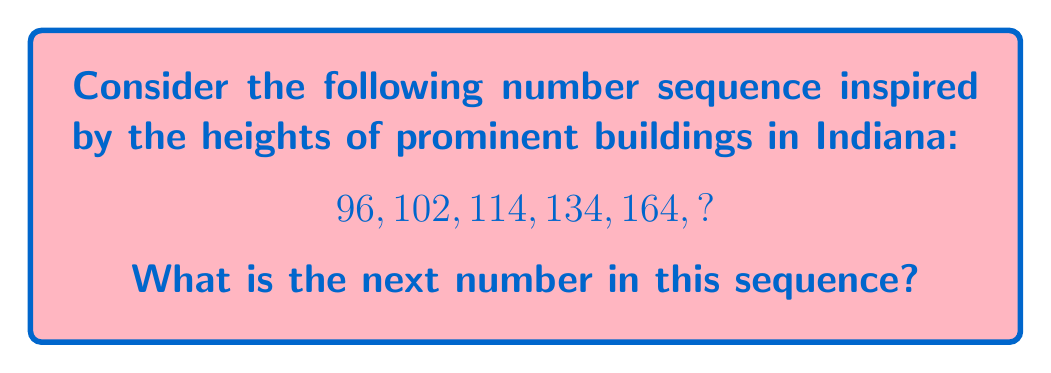Help me with this question. Let's approach this step-by-step:

1) First, let's look at the differences between consecutive terms:
   96 to 102: +6
   102 to 114: +12
   114 to 134: +20
   134 to 164: +30

2) We can observe that the differences themselves are increasing. Let's look at how they increase:
   6 to 12: +6
   12 to 20: +8
   20 to 30: +10

3) We see that the increase in the differences is also following a pattern:
   +6, +8, +10

4) This suggests that the next increase in the difference will be +12

5) So, the next difference should be:
   30 + 12 = 42

6) Therefore, to find the next term in the original sequence, we add this new difference to the last term:
   164 + 42 = 206

Thus, the next number in the sequence is 206.

This sequence could represent the heights (in feet) of increasingly taller buildings in Indiana, with each new building not only being taller but increasing in height at a faster rate than the previous one, mimicking the architectural ambition often seen in urban development.
Answer: 206 